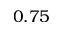Convert formula to latex. <formula><loc_0><loc_0><loc_500><loc_500>0 . 7 5</formula> 